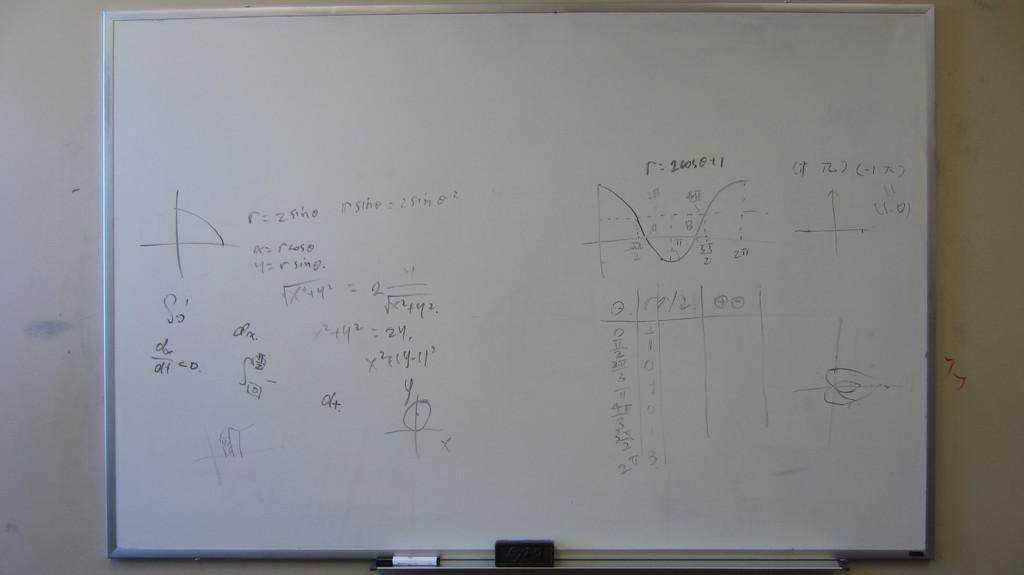<image>
Render a clear and concise summary of the photo. A white board full of equations and graph diagrams, one where r:2605041 